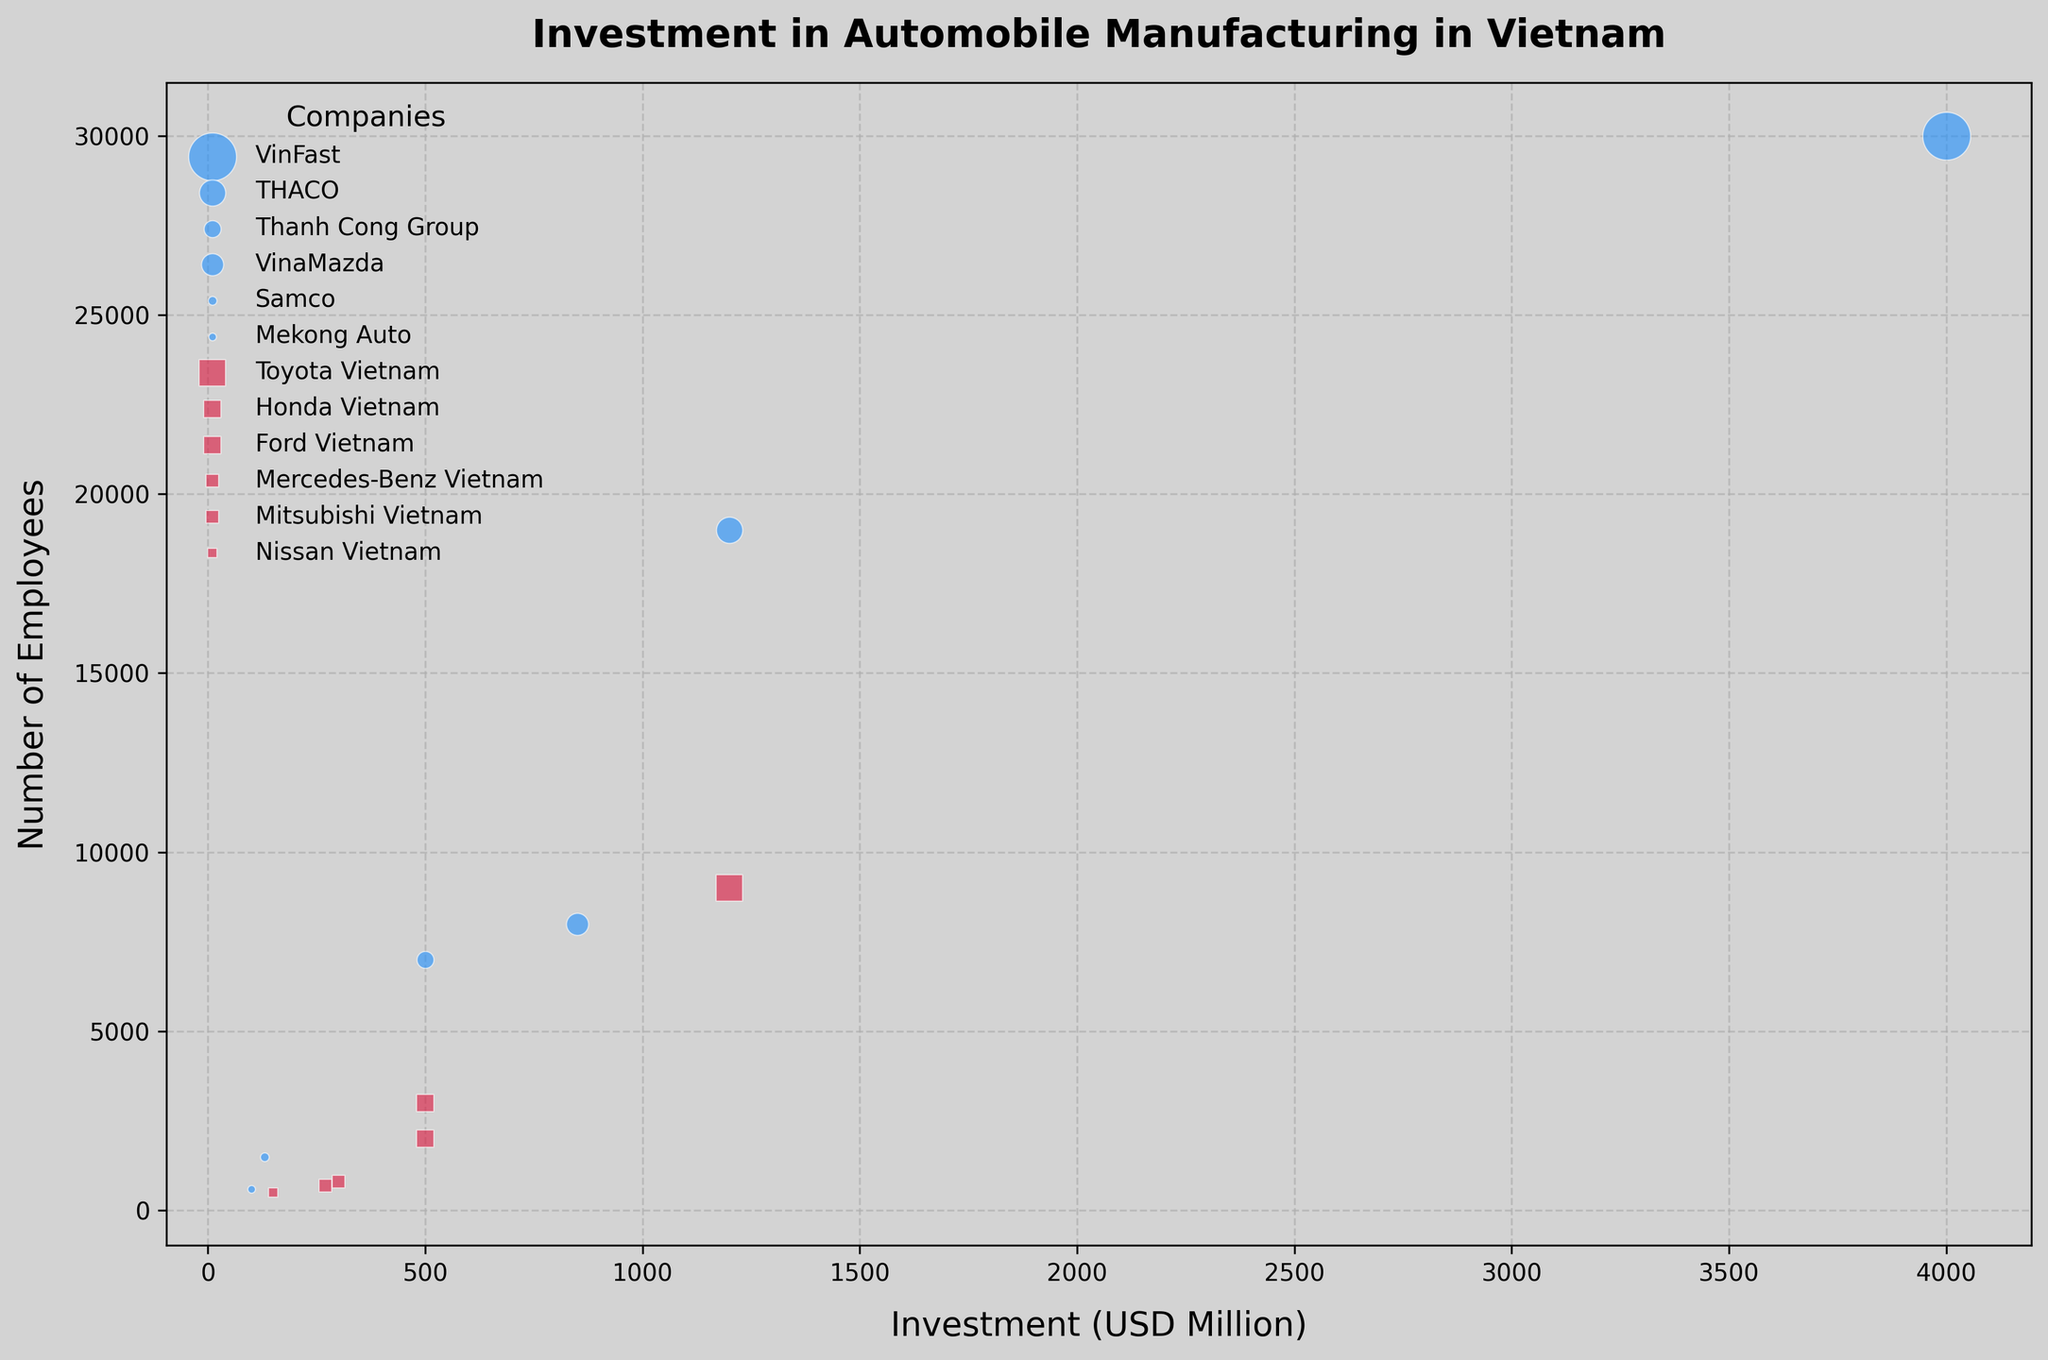What is the company with the most significant investment and how many employees does it have? VinFast has the largest bubble; check the investment and employees corresponding to VinFast.
Answer: 30000 Which company has the least number of employees and what is its investment amount? Find the smallest bubble; check the employees and investment corresponding to the least number of employees.
Answer: Mekong Auto, 100 USD Million How does the investment for Toyota Vietnam compare with VinFast? Look at the relative size of the bubbles for Toyota Vietnam and VinFast; Toyota has an investment of 1200 USD Million and VinFast has 4000 USD Million.
Answer: VinFast has a higher investment What is the total investment of foreign companies combined? Sum up the investment amounts for all foreign companies: Toyota Vietnam (1200) + Honda Vietnam (500) + Ford Vietnam (500) + Mercedes-Benz Vietnam (300) + Mitsubishi Vietnam (270) + Nissan Vietnam (150).
Answer: 2920 USD Million Which company type has more average employees per company, domestic or foreign? Calculate the average number of employees for domestic companies and foreign companies and compare. Domestic: (30000 + 19000 + 7000 + 8000 + 1500 + 600) / 6 = 10833.33; Foreign: (9000 + 3000 + 2000 + 800 + 700 + 500) / 6 = 2666.67.
Answer: Domestic Which has a bigger bubble size, Thanh Cong Group or Ford Vietnam? Compare the bubble sizes; both companies have an investment of 500 USD Million; hence the bubble sizes are comparable.
Answer: Same What is the approximate ratio of investments between the largest foreign company and the largest domestic company? Largest foreign company is Toyota Vietnam with 1200 USD Million; largest domestic company is VinFast with 4000 USD Million. The ratio is 1200/4000.
Answer: 3:10 How many companies have investments greater than 500 USD Million? Identify bubbles with investment more than 500 USD Million and count them. Companies: VinFast, THACO, VinaMazda, Toyota Vietnam. Total is 4.
Answer: 4 Compare the number of employees between the domestic company with the second-highest investment and the foreign company with the second-highest investment. THACO has the second-highest investment among domestic with 1200 USD Million; Honda Vietnam has it among foreign with 500 USD Million. THACO: 19000 employees; Honda Vietnam: 3000 employees.
Answer: THACO has more employees Are there more companies with investments less than 500 USD Million or more than 500 USD Million? Count companies with less than 500 USD Million investments and those with more. Less: Samco, Mekong Auto, Mitsubishi Vietnam, Nissan Vietnam = 4. More: VinFast, THACO, Thanh Cong Group, VinaMazda, Toyota Vietnam, Honda Vietnam, Ford Vietnam, Mercedes-Benz Vietnam = 8.
Answer: More with more than 500 USD Million investments 